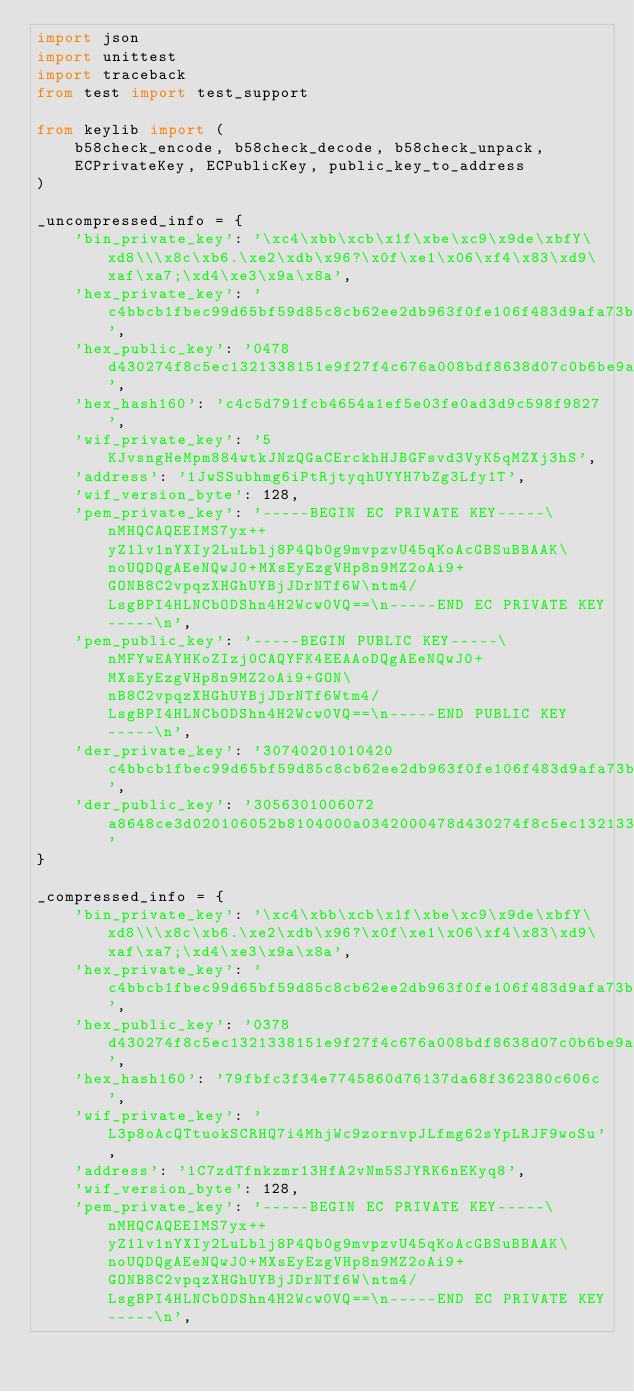<code> <loc_0><loc_0><loc_500><loc_500><_Python_>import json
import unittest
import traceback
from test import test_support

from keylib import (
    b58check_encode, b58check_decode, b58check_unpack,
    ECPrivateKey, ECPublicKey, public_key_to_address
)

_uncompressed_info = {
    'bin_private_key': '\xc4\xbb\xcb\x1f\xbe\xc9\x9de\xbfY\xd8\\\x8c\xb6.\xe2\xdb\x96?\x0f\xe1\x06\xf4\x83\xd9\xaf\xa7;\xd4\xe3\x9a\x8a',
    'hex_private_key': 'c4bbcb1fbec99d65bf59d85c8cb62ee2db963f0fe106f483d9afa73bd4e39a8a',
    'hex_public_key': '0478d430274f8c5ec1321338151e9f27f4c676a008bdf8638d07c0b6be9ab35c71a1518063243acd4dfe96b66e3f2ec8013c8e072cd09b3834a19f81f659cc3455',
    'hex_hash160': 'c4c5d791fcb4654a1ef5e03fe0ad3d9c598f9827',
    'wif_private_key': '5KJvsngHeMpm884wtkJNzQGaCErckhHJBGFsvd3VyK5qMZXj3hS',
    'address': '1JwSSubhmg6iPtRjtyqhUYYH7bZg3Lfy1T',
    'wif_version_byte': 128,
    'pem_private_key': '-----BEGIN EC PRIVATE KEY-----\nMHQCAQEEIMS7yx++yZ1lv1nYXIy2LuLblj8P4Qb0g9mvpzvU45qKoAcGBSuBBAAK\noUQDQgAEeNQwJ0+MXsEyEzgVHp8n9MZ2oAi9+GONB8C2vpqzXHGhUYBjJDrNTf6W\ntm4/LsgBPI4HLNCbODShn4H2Wcw0VQ==\n-----END EC PRIVATE KEY-----\n',
    'pem_public_key': '-----BEGIN PUBLIC KEY-----\nMFYwEAYHKoZIzj0CAQYFK4EEAAoDQgAEeNQwJ0+MXsEyEzgVHp8n9MZ2oAi9+GON\nB8C2vpqzXHGhUYBjJDrNTf6Wtm4/LsgBPI4HLNCbODShn4H2Wcw0VQ==\n-----END PUBLIC KEY-----\n',
    'der_private_key': '30740201010420c4bbcb1fbec99d65bf59d85c8cb62ee2db963f0fe106f483d9afa73bd4e39a8aa00706052b8104000aa1440342000478d430274f8c5ec1321338151e9f27f4c676a008bdf8638d07c0b6be9ab35c71a1518063243acd4dfe96b66e3f2ec8013c8e072cd09b3834a19f81f659cc3455',
    'der_public_key': '3056301006072a8648ce3d020106052b8104000a0342000478d430274f8c5ec1321338151e9f27f4c676a008bdf8638d07c0b6be9ab35c71a1518063243acd4dfe96b66e3f2ec8013c8e072cd09b3834a19f81f659cc3455'
}

_compressed_info = {
    'bin_private_key': '\xc4\xbb\xcb\x1f\xbe\xc9\x9de\xbfY\xd8\\\x8c\xb6.\xe2\xdb\x96?\x0f\xe1\x06\xf4\x83\xd9\xaf\xa7;\xd4\xe3\x9a\x8a',
    'hex_private_key': 'c4bbcb1fbec99d65bf59d85c8cb62ee2db963f0fe106f483d9afa73bd4e39a8a01',
    'hex_public_key': '0378d430274f8c5ec1321338151e9f27f4c676a008bdf8638d07c0b6be9ab35c71',
    'hex_hash160': '79fbfc3f34e7745860d76137da68f362380c606c',
    'wif_private_key': 'L3p8oAcQTtuokSCRHQ7i4MhjWc9zornvpJLfmg62sYpLRJF9woSu',
    'address': '1C7zdTfnkzmr13HfA2vNm5SJYRK6nEKyq8',
    'wif_version_byte': 128,
    'pem_private_key': '-----BEGIN EC PRIVATE KEY-----\nMHQCAQEEIMS7yx++yZ1lv1nYXIy2LuLblj8P4Qb0g9mvpzvU45qKoAcGBSuBBAAK\noUQDQgAEeNQwJ0+MXsEyEzgVHp8n9MZ2oAi9+GONB8C2vpqzXHGhUYBjJDrNTf6W\ntm4/LsgBPI4HLNCbODShn4H2Wcw0VQ==\n-----END EC PRIVATE KEY-----\n',</code> 